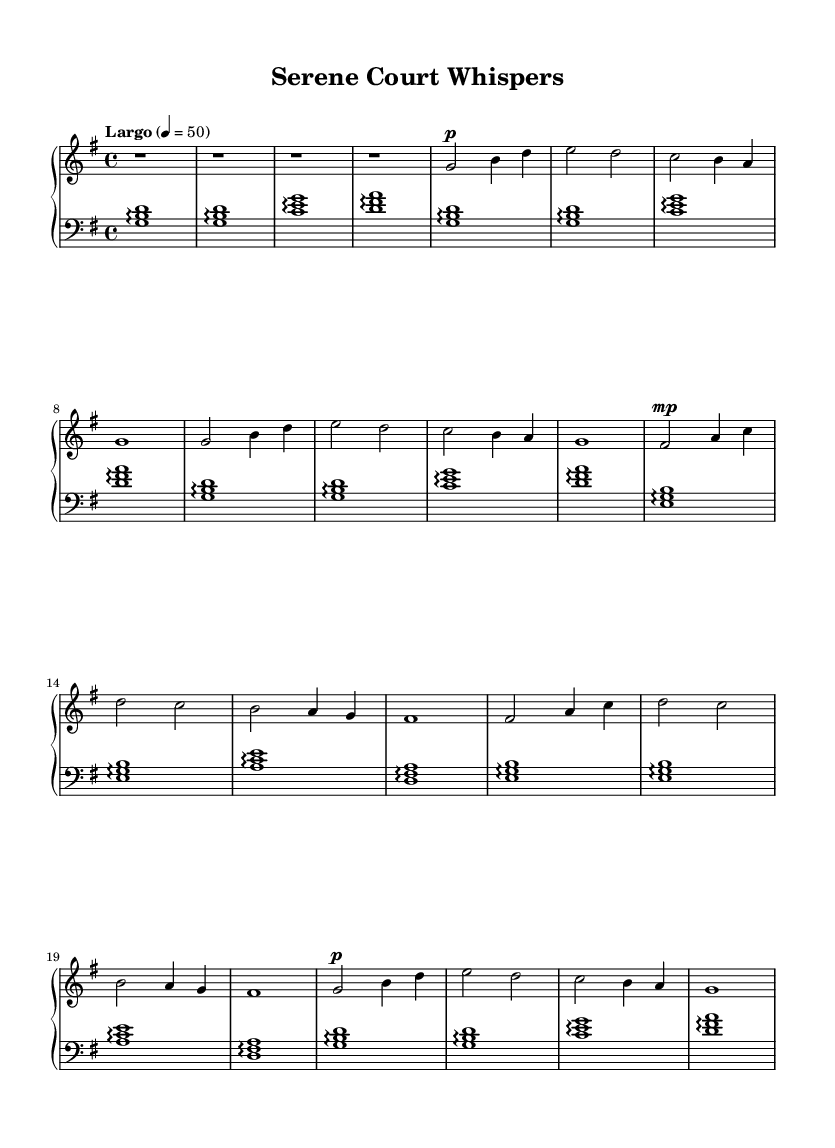what is the key signature of this music? The key signature is G major, which has one sharp. This can be determined by identifying the signature at the beginning of the music, which shows that F is sharp.
Answer: G major what is the time signature of this music? The time signature is four-four, as indicated by the notation at the beginning of the score. This means there are four beats in each measure.
Answer: four-four what is the tempo marking of this piece? The tempo marking is "Largo," which is indicated at the beginning of the score. This term generally indicates a slow tempo.
Answer: Largo how many measures are in the Main Theme A section? Main Theme A consists of four measures, which can be counted from the notation where the thematic material appears under it.
Answer: four what instrument is primarily used in this score? The primary instrument used in this score is the piano, which is indicated by the notation "PianoStaff" at the beginning.
Answer: piano what dynamic marking is used at the beginning of the Main Theme A? The dynamic marking at the beginning of Main Theme A is "piano," which indicates a soft volume. This is seen at the start of the measures for Main Theme A.
Answer: piano why do the left-hand notes primarily use arpeggios? The left-hand notes use arpeggios to create a flowing and harmonious background for the melody, providing a serene atmosphere, which complements the idea of relaxation in post-match recovery. This technique supports the overall musical texture and serves the calming theme.
Answer: to create a flowing background 